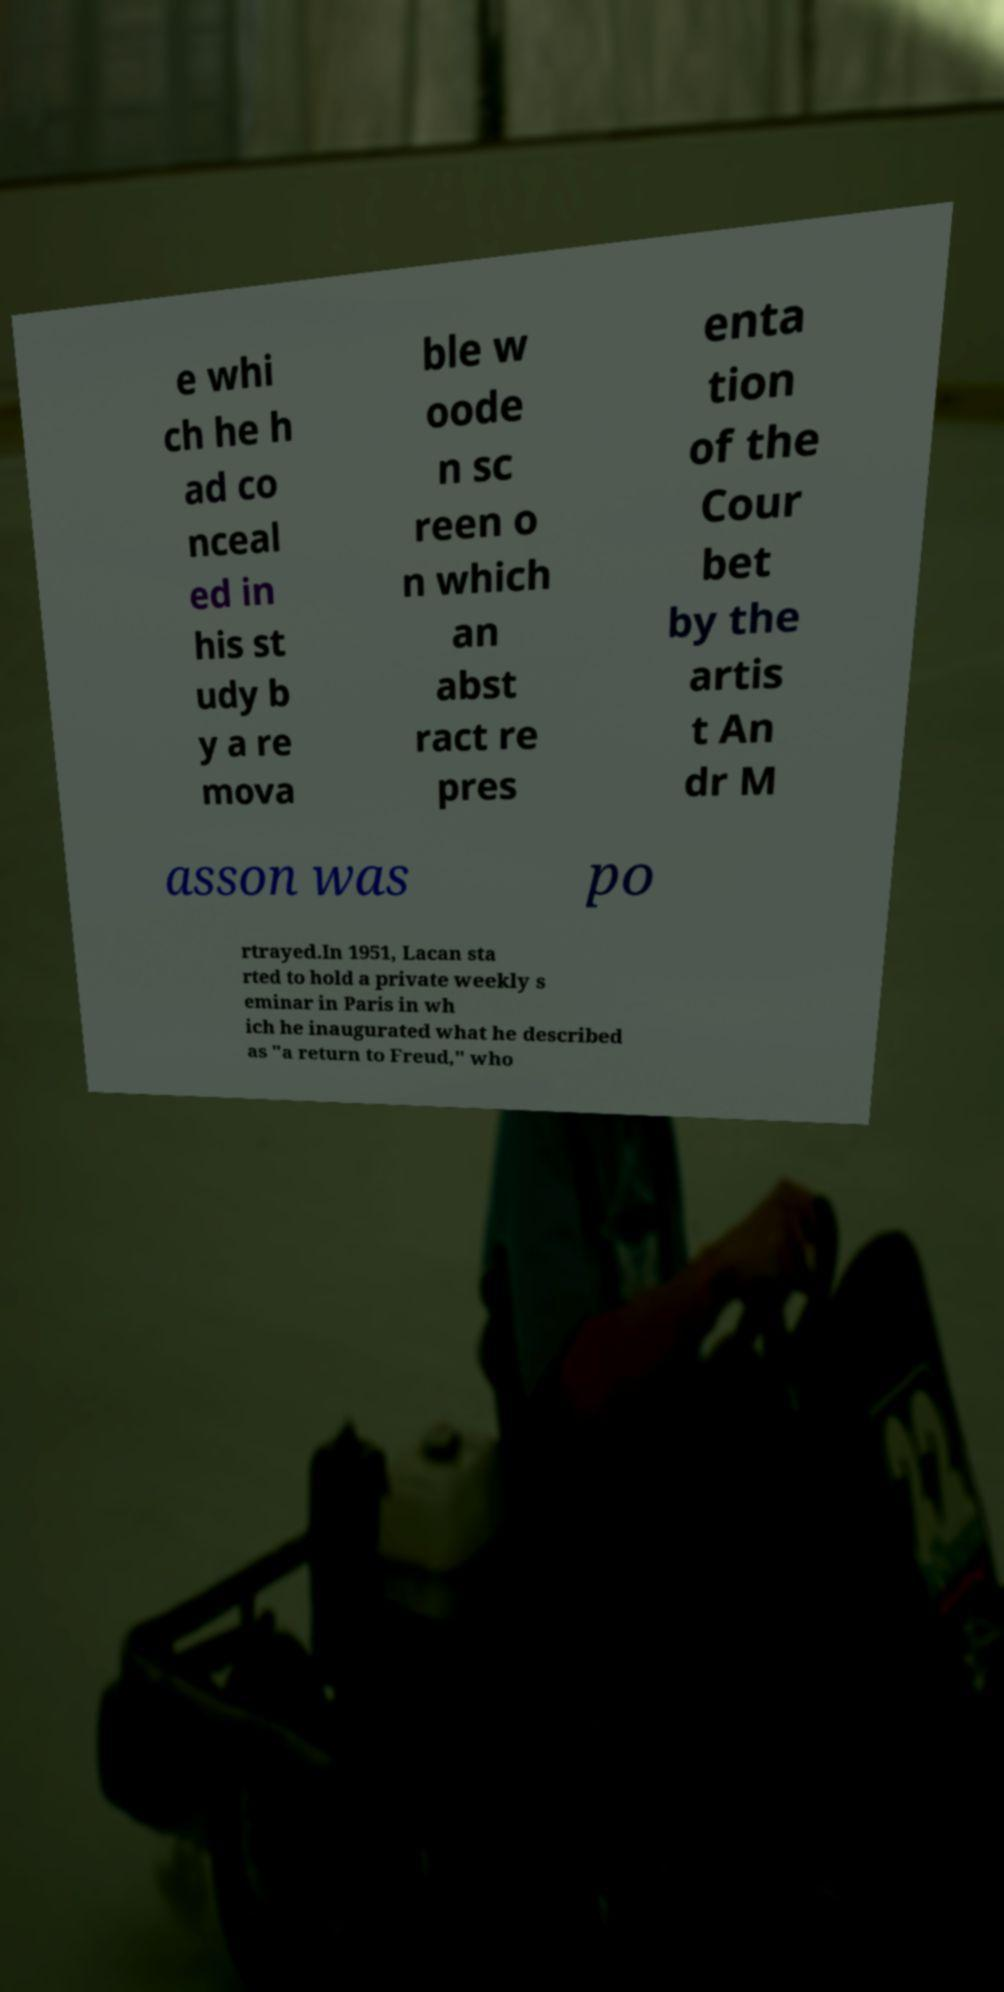Can you read and provide the text displayed in the image?This photo seems to have some interesting text. Can you extract and type it out for me? e whi ch he h ad co nceal ed in his st udy b y a re mova ble w oode n sc reen o n which an abst ract re pres enta tion of the Cour bet by the artis t An dr M asson was po rtrayed.In 1951, Lacan sta rted to hold a private weekly s eminar in Paris in wh ich he inaugurated what he described as "a return to Freud," who 